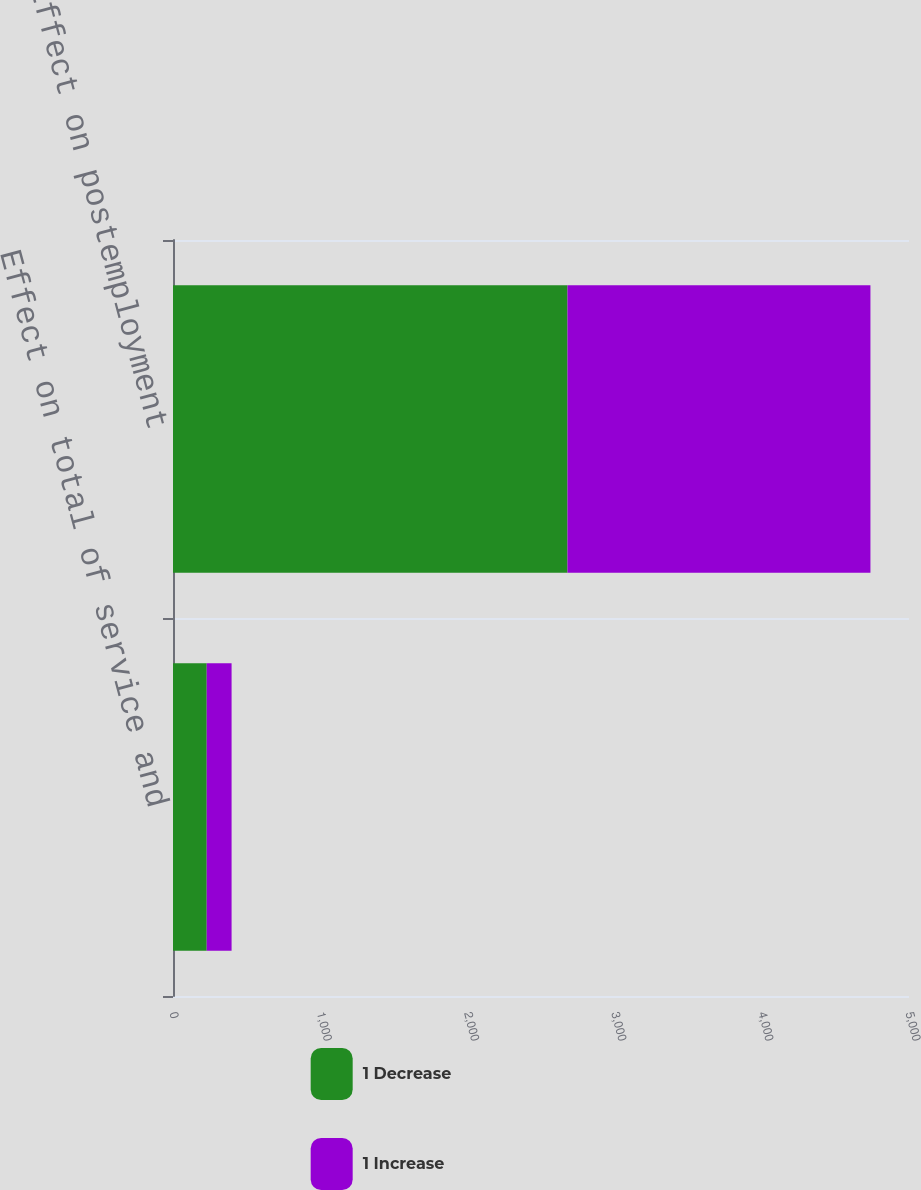Convert chart. <chart><loc_0><loc_0><loc_500><loc_500><stacked_bar_chart><ecel><fcel>Effect on total of service and<fcel>Effect on postemployment<nl><fcel>1 Decrease<fcel>229<fcel>2680<nl><fcel>1 Increase<fcel>169<fcel>2058<nl></chart> 